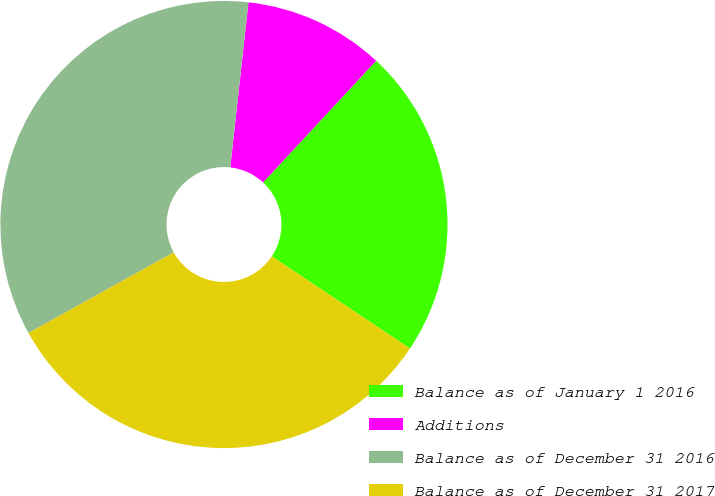Convert chart to OTSL. <chart><loc_0><loc_0><loc_500><loc_500><pie_chart><fcel>Balance as of January 1 2016<fcel>Additions<fcel>Balance as of December 31 2016<fcel>Balance as of December 31 2017<nl><fcel>22.44%<fcel>10.17%<fcel>34.81%<fcel>32.57%<nl></chart> 